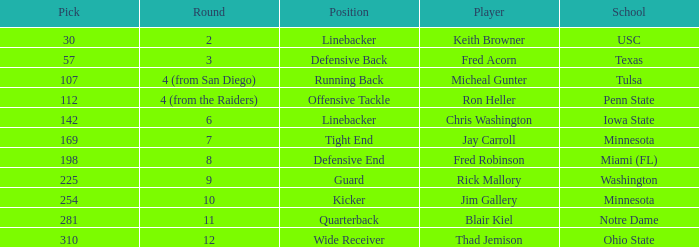What is the highest pick from Washington? 225.0. 